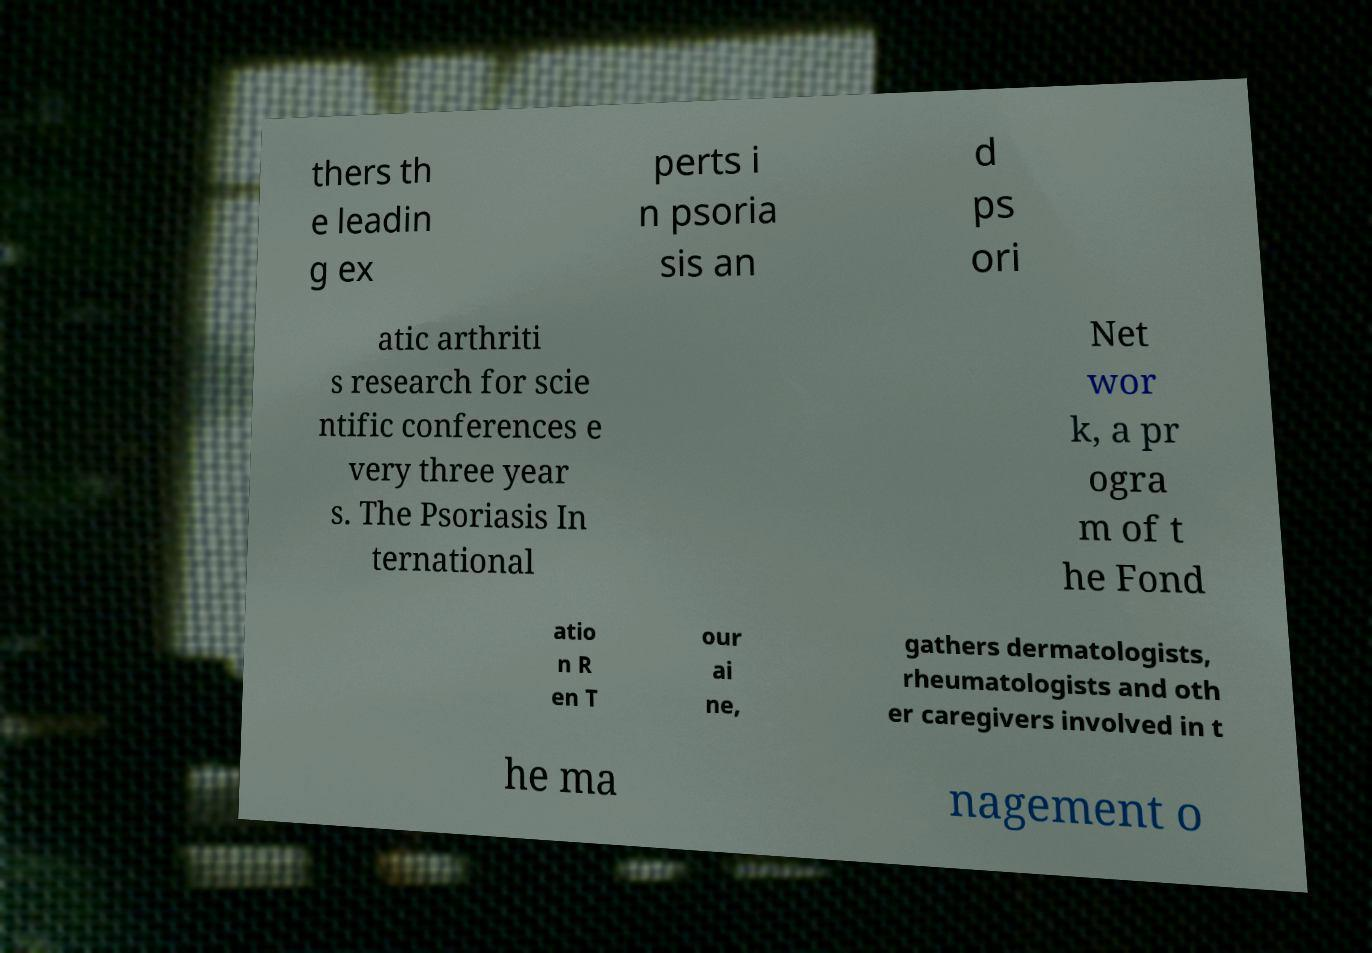Can you read and provide the text displayed in the image?This photo seems to have some interesting text. Can you extract and type it out for me? thers th e leadin g ex perts i n psoria sis an d ps ori atic arthriti s research for scie ntific conferences e very three year s. The Psoriasis In ternational Net wor k, a pr ogra m of t he Fond atio n R en T our ai ne, gathers dermatologists, rheumatologists and oth er caregivers involved in t he ma nagement o 